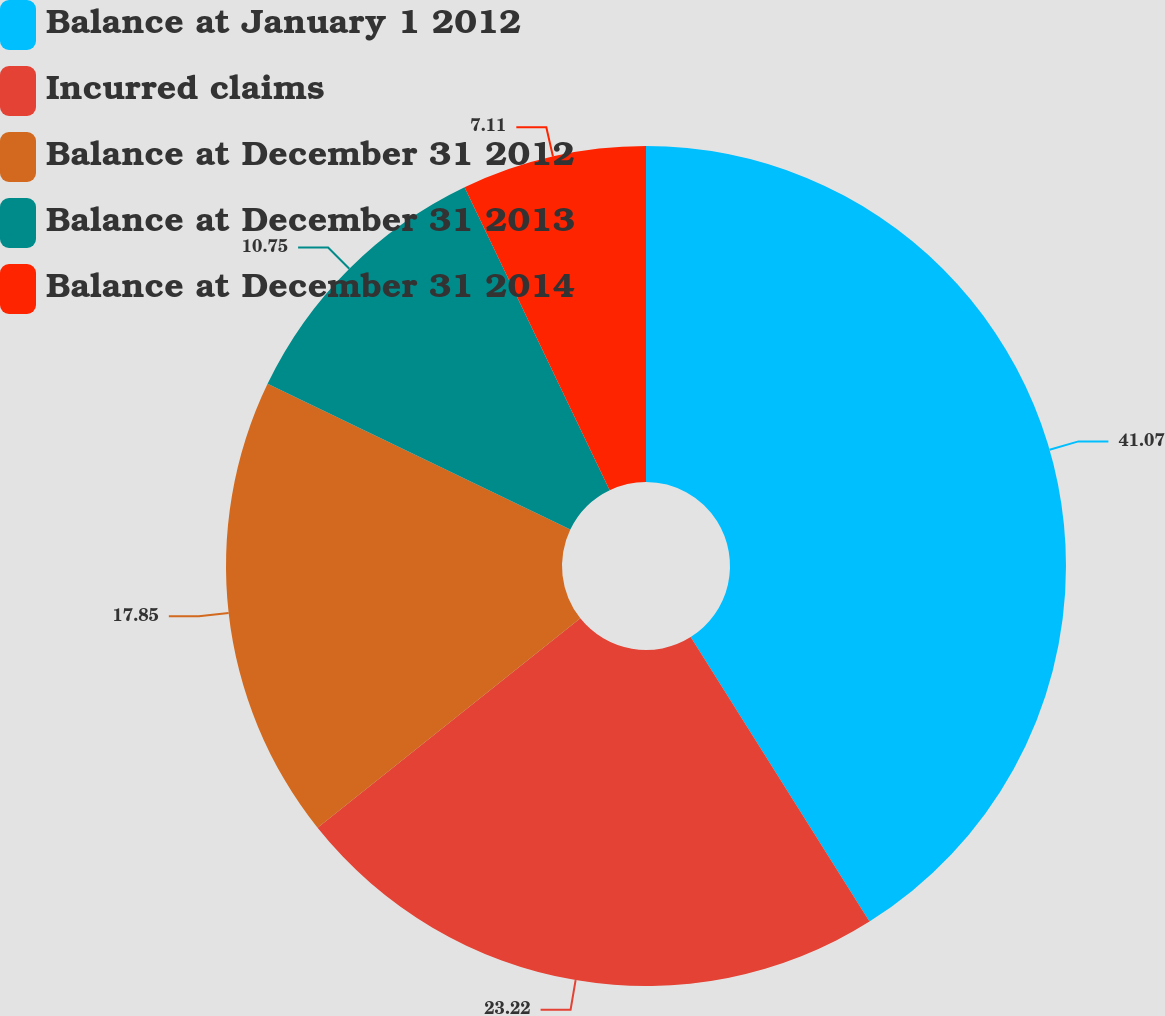<chart> <loc_0><loc_0><loc_500><loc_500><pie_chart><fcel>Balance at January 1 2012<fcel>Incurred claims<fcel>Balance at December 31 2012<fcel>Balance at December 31 2013<fcel>Balance at December 31 2014<nl><fcel>41.07%<fcel>23.22%<fcel>17.85%<fcel>10.75%<fcel>7.11%<nl></chart> 